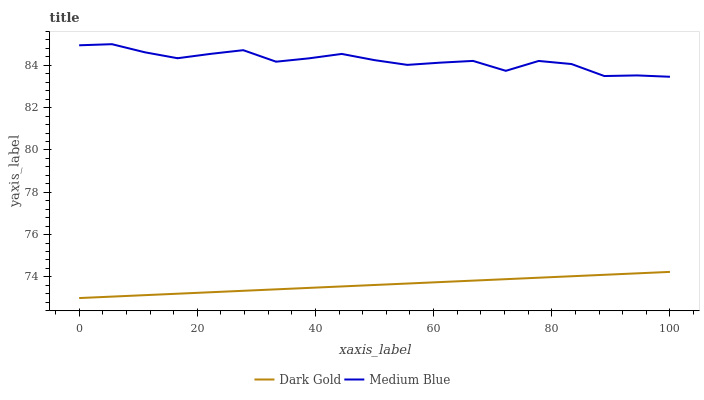Does Dark Gold have the maximum area under the curve?
Answer yes or no. No. Is Dark Gold the roughest?
Answer yes or no. No. Does Dark Gold have the highest value?
Answer yes or no. No. Is Dark Gold less than Medium Blue?
Answer yes or no. Yes. Is Medium Blue greater than Dark Gold?
Answer yes or no. Yes. Does Dark Gold intersect Medium Blue?
Answer yes or no. No. 